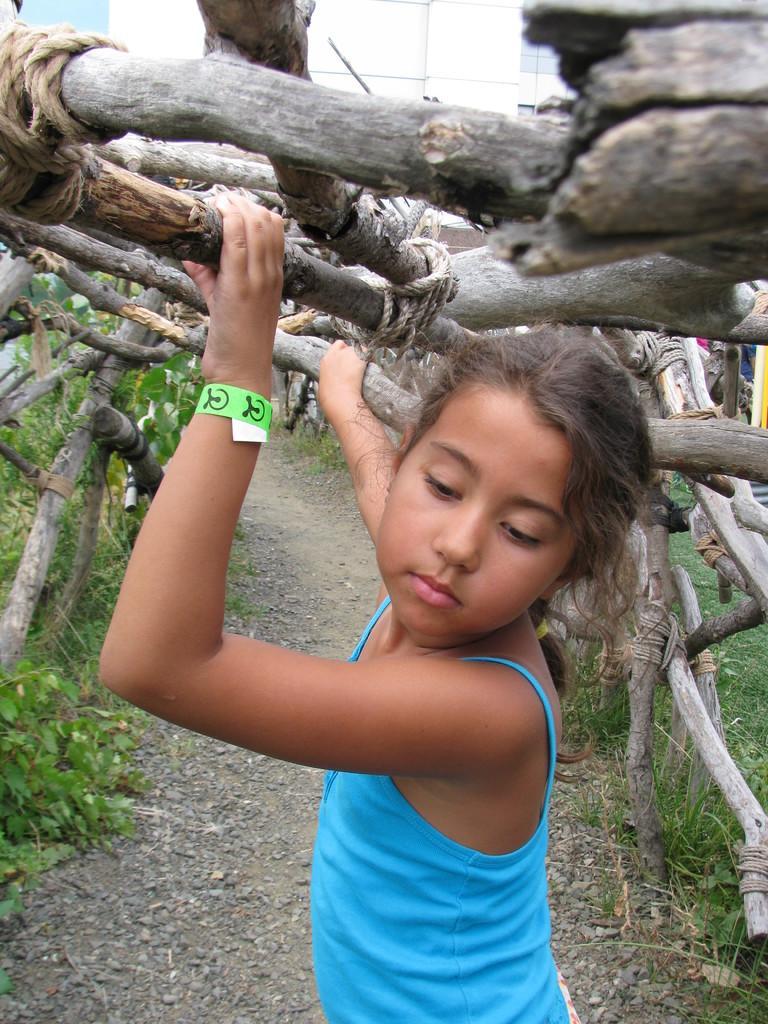Can you describe this image briefly? In the image there is a girl standing. And there is a band on her hand. Above her there are wooden sticks with ropes. In the background there are wooden poles. On the ground there are stones and also there are small plants. 